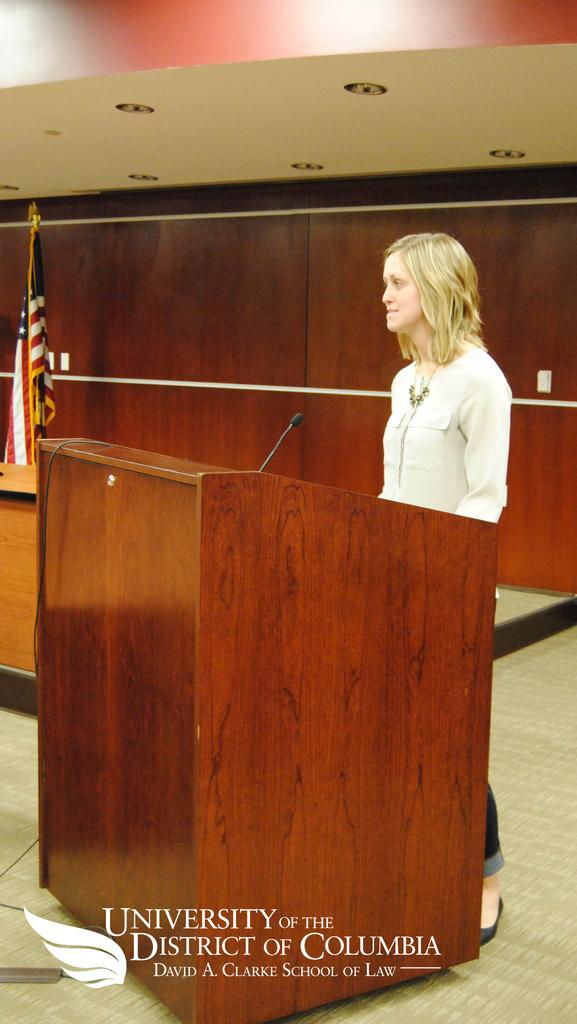What is the main subject of the image? The main subject of the image is a woman. Where is the woman standing in the image? The woman is standing in front of a wooden stand. What is on the wooden stand? There is a microphone on the wooden stand. What can be seen in the left corner of the image? There is a flag in the left corner of the image. What type of railway is visible in the image? There is no railway present in the image. How many hydrants can be seen in the image? There are no hydrants present in the image. 